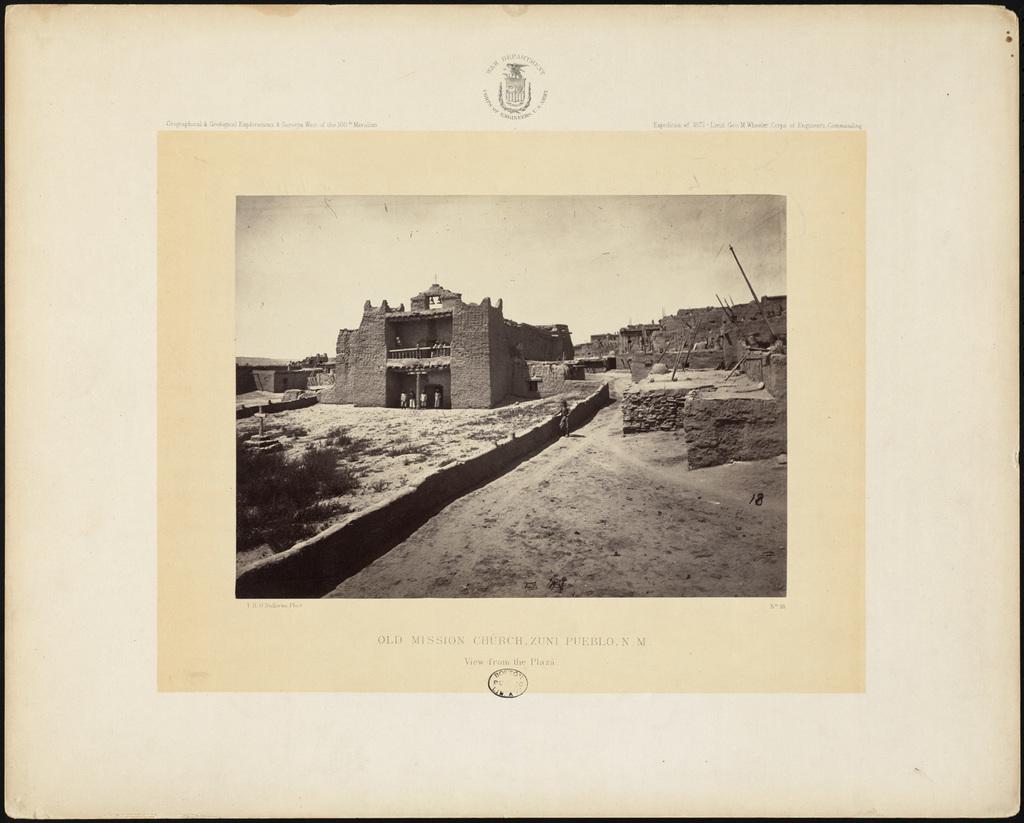What number is written in black on the right inside the frame?
Keep it short and to the point. 18. What is the name of this church?
Give a very brief answer. Old mission church. 